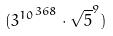Convert formula to latex. <formula><loc_0><loc_0><loc_500><loc_500>( { 3 ^ { 1 0 } } ^ { 3 6 8 } \cdot \sqrt { 5 } ^ { 9 } )</formula> 